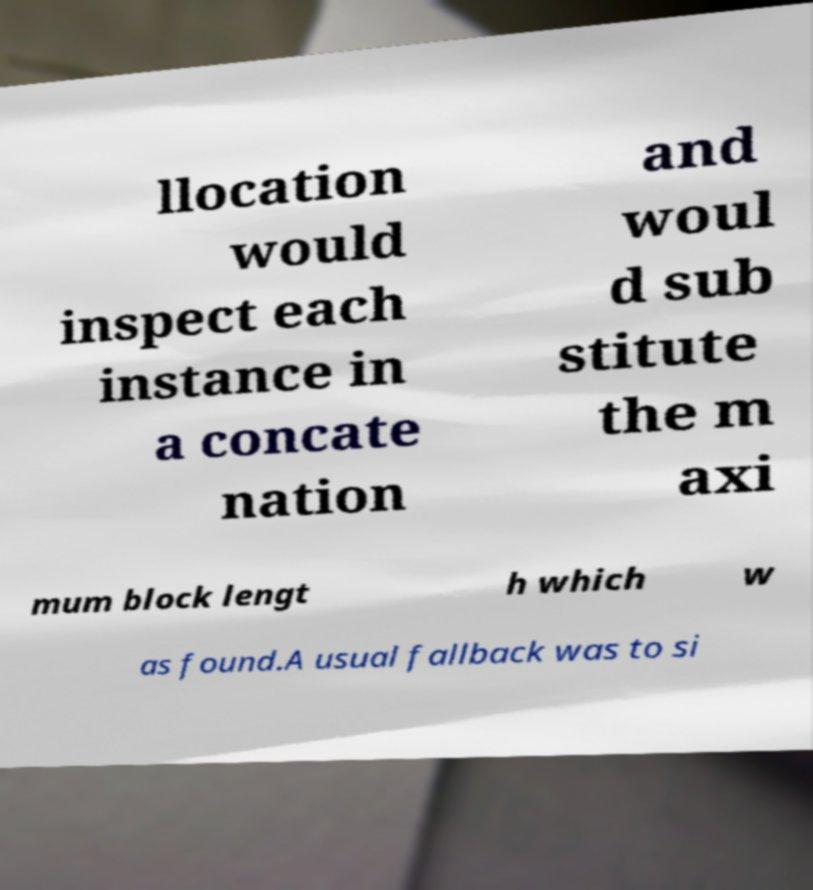Could you extract and type out the text from this image? llocation would inspect each instance in a concate nation and woul d sub stitute the m axi mum block lengt h which w as found.A usual fallback was to si 